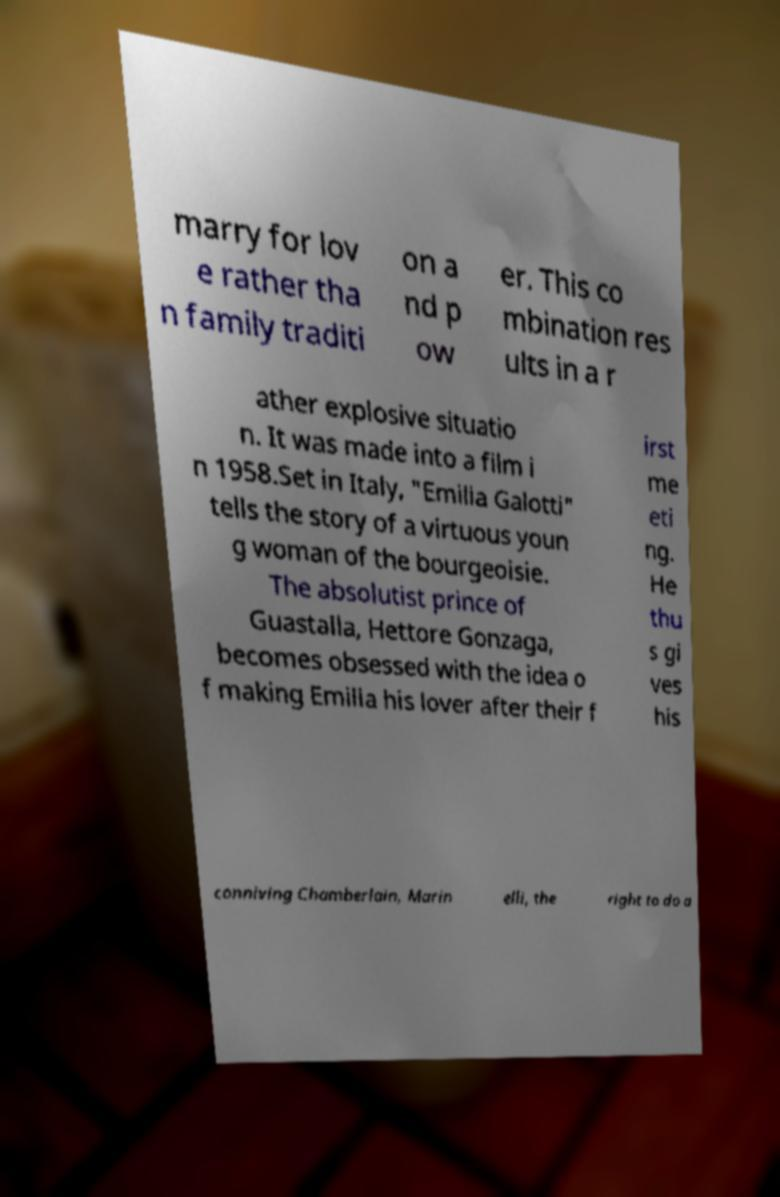Could you assist in decoding the text presented in this image and type it out clearly? marry for lov e rather tha n family traditi on a nd p ow er. This co mbination res ults in a r ather explosive situatio n. It was made into a film i n 1958.Set in Italy, "Emilia Galotti" tells the story of a virtuous youn g woman of the bourgeoisie. The absolutist prince of Guastalla, Hettore Gonzaga, becomes obsessed with the idea o f making Emilia his lover after their f irst me eti ng. He thu s gi ves his conniving Chamberlain, Marin elli, the right to do a 